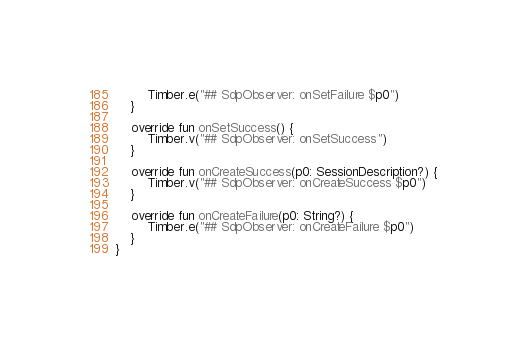<code> <loc_0><loc_0><loc_500><loc_500><_Kotlin_>        Timber.e("## SdpObserver: onSetFailure $p0")
    }

    override fun onSetSuccess() {
        Timber.v("## SdpObserver: onSetSuccess")
    }

    override fun onCreateSuccess(p0: SessionDescription?) {
        Timber.v("## SdpObserver: onCreateSuccess $p0")
    }

    override fun onCreateFailure(p0: String?) {
        Timber.e("## SdpObserver: onCreateFailure $p0")
    }
}
</code> 